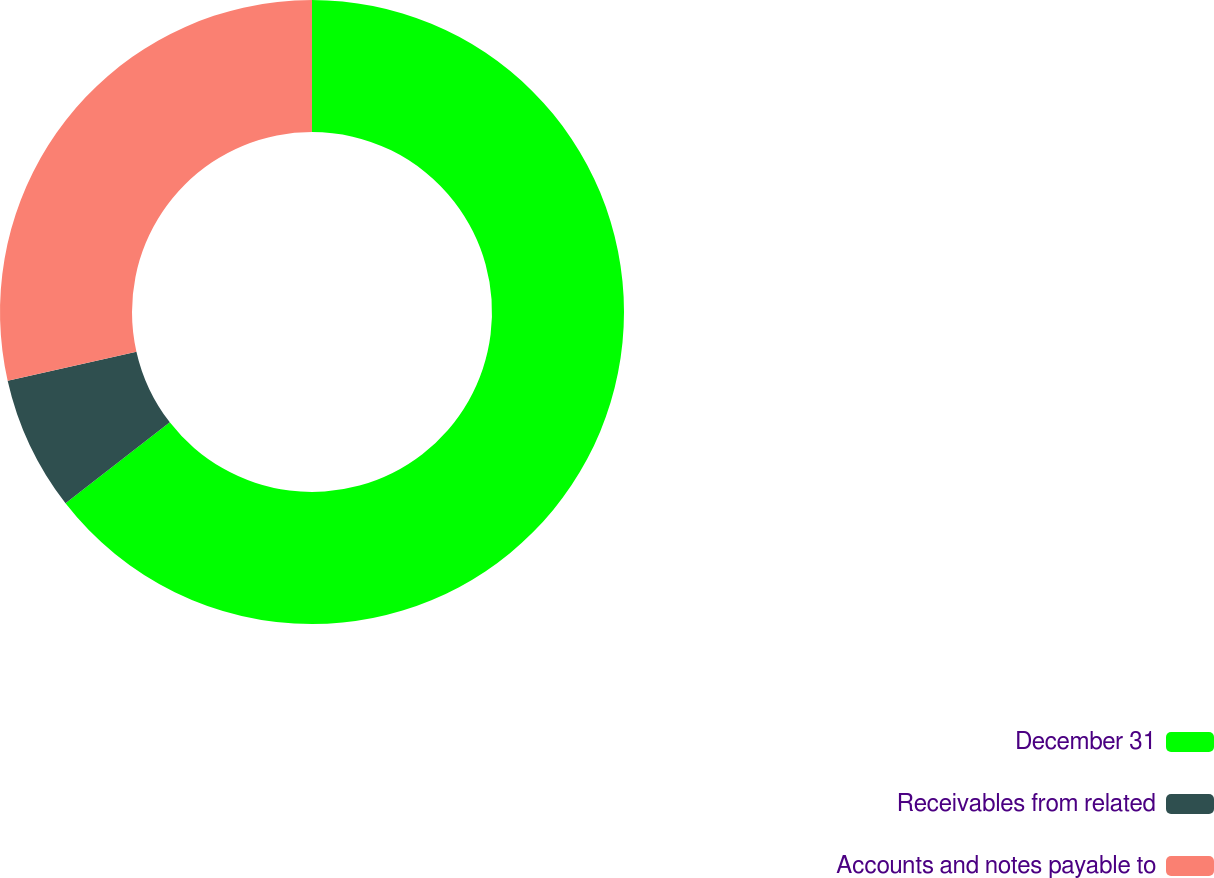Convert chart. <chart><loc_0><loc_0><loc_500><loc_500><pie_chart><fcel>December 31<fcel>Receivables from related<fcel>Accounts and notes payable to<nl><fcel>64.49%<fcel>6.97%<fcel>28.53%<nl></chart> 